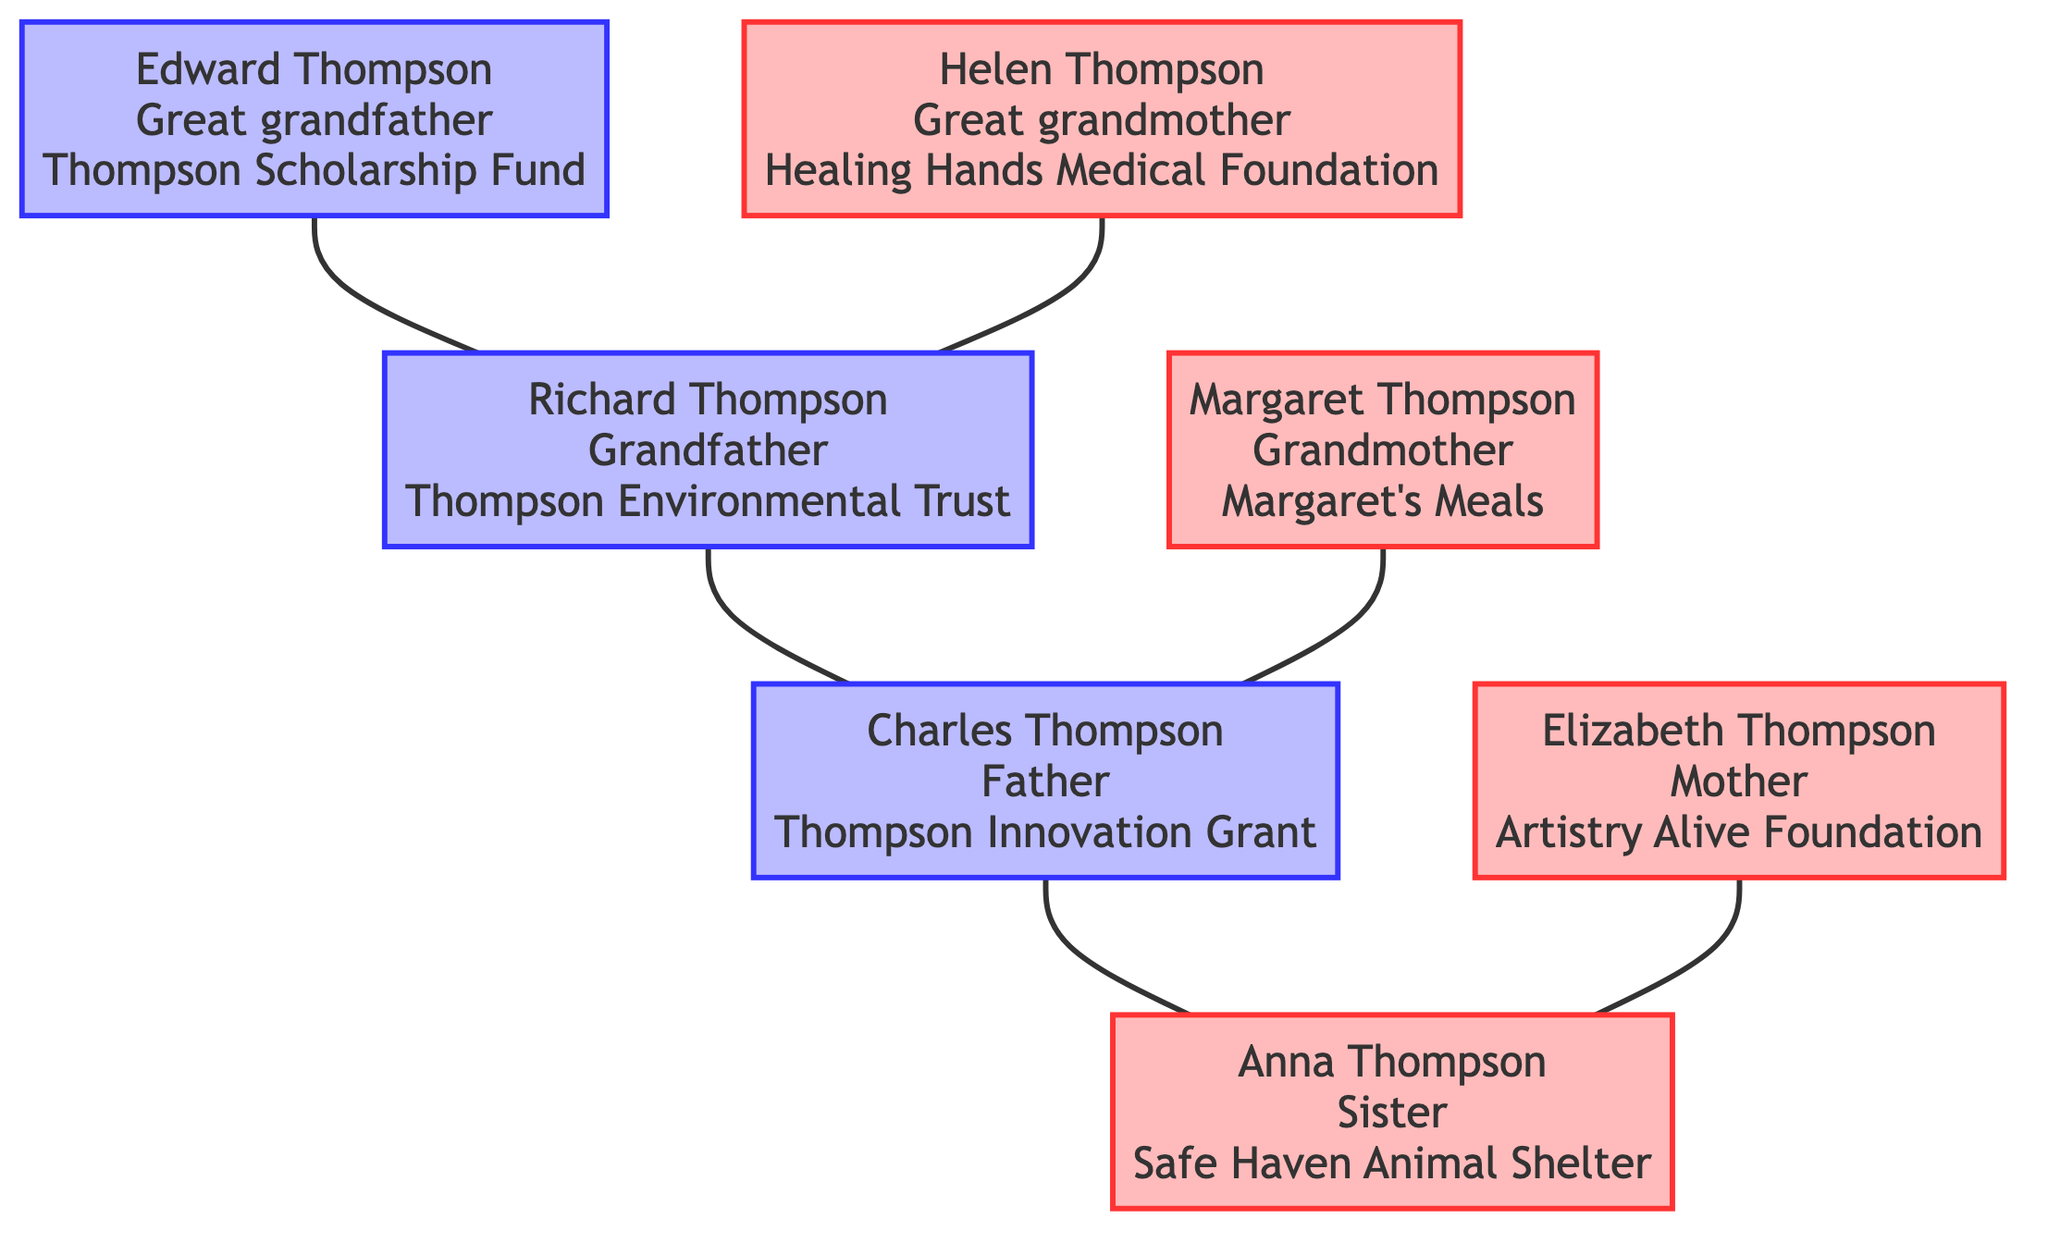What charity does Edward Thompson support? The diagram specifies that Edward Thompson supports the "Thompson Scholarship Fund." This is found directly under his node in the family tree.
Answer: Thompson Scholarship Fund How many generations are represented in the diagram? The diagram includes three generations: great grandparents (Edward and Helen), grandparents (Richard and Margaret), and parents (Charles and Elizabeth) along with a sister (Anna). Therefore, there are three generations in total.
Answer: 3 Who is Richard Thompson's spouse? By analyzing the connections in the diagram, it's clear that Margaret Thompson is connected to Richard Thompson as his spouse, which is evident in the diagram showing a lineage connecting them.
Answer: Margaret Thompson What is the focus of the charity supported by Anna Thompson? The diagram indicates that Anna Thompson supports "Safe Haven Animal Shelter" which focuses on animal welfare. This information can be found in her node.
Answer: Animal Welfare Which family member supports a charity focused on technology and innovation? The diagram indicates that Charles Thompson supports the "Thompson Innovation Grant," which focuses on technology and innovation, as listed in his philanthropy information.
Answer: Thompson Innovation Grant How many charities focused on education are represented? The diagram only shows one charity focused on education, which is the "Thompson Scholarship Fund," supported by Edward Thompson. So, there is only one education-focused charity in the diagram.
Answer: 1 Who has a focus on healthcare in their philanthropic endeavors? According to the diagram, Helen Thompson's charity, "Healing Hands Medical Foundation," has a focus on healthcare, which is indicated under her node.
Answer: Helen Thompson What type of causes does Margaret Thompson support? The diagram shows that Margaret Thompson supports "Margaret's Meals," which is specifically focused on hunger relief. Thus, she supports causes related to hunger relief.
Answer: Hunger Relief Which family member is involved in the arts and culture? The diagram identifies Elizabeth Thompson as supporting the "Artistry Alive Foundation," which promotes arts and culture, clearly indicating her involvement in that area.
Answer: Elizabeth Thompson 